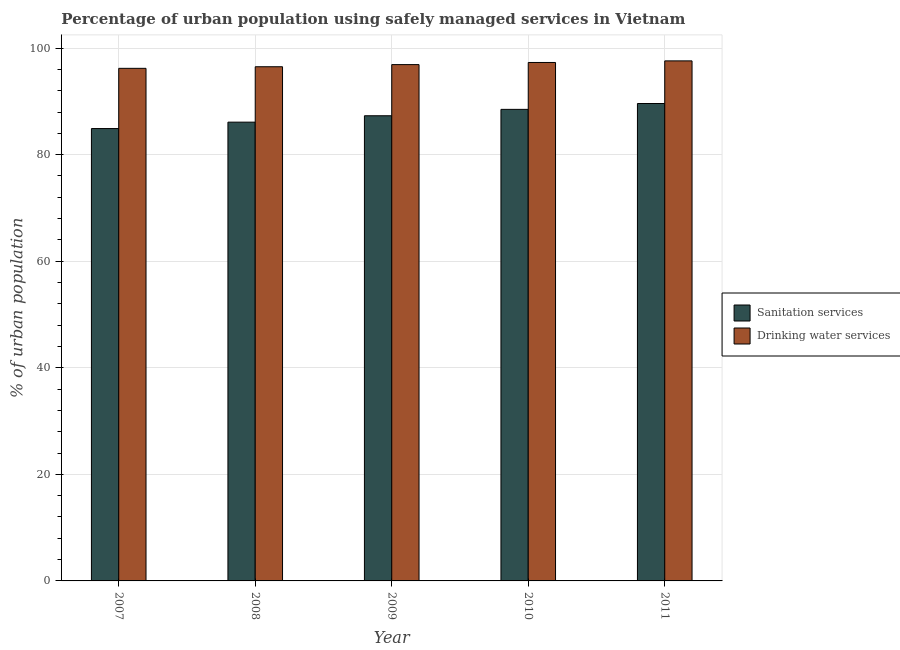How many different coloured bars are there?
Your answer should be very brief. 2. How many groups of bars are there?
Offer a very short reply. 5. How many bars are there on the 5th tick from the right?
Make the answer very short. 2. In how many cases, is the number of bars for a given year not equal to the number of legend labels?
Keep it short and to the point. 0. What is the percentage of urban population who used sanitation services in 2008?
Keep it short and to the point. 86.1. Across all years, what is the maximum percentage of urban population who used sanitation services?
Your answer should be compact. 89.6. Across all years, what is the minimum percentage of urban population who used drinking water services?
Make the answer very short. 96.2. In which year was the percentage of urban population who used drinking water services maximum?
Offer a very short reply. 2011. In which year was the percentage of urban population who used sanitation services minimum?
Your response must be concise. 2007. What is the total percentage of urban population who used drinking water services in the graph?
Ensure brevity in your answer.  484.5. What is the difference between the percentage of urban population who used drinking water services in 2008 and that in 2011?
Your answer should be very brief. -1.1. What is the difference between the percentage of urban population who used sanitation services in 2007 and the percentage of urban population who used drinking water services in 2009?
Offer a very short reply. -2.4. What is the average percentage of urban population who used drinking water services per year?
Offer a very short reply. 96.9. In the year 2009, what is the difference between the percentage of urban population who used drinking water services and percentage of urban population who used sanitation services?
Your answer should be compact. 0. What is the ratio of the percentage of urban population who used drinking water services in 2009 to that in 2011?
Give a very brief answer. 0.99. What is the difference between the highest and the second highest percentage of urban population who used sanitation services?
Give a very brief answer. 1.1. What is the difference between the highest and the lowest percentage of urban population who used sanitation services?
Ensure brevity in your answer.  4.7. In how many years, is the percentage of urban population who used drinking water services greater than the average percentage of urban population who used drinking water services taken over all years?
Your answer should be compact. 2. Is the sum of the percentage of urban population who used drinking water services in 2009 and 2011 greater than the maximum percentage of urban population who used sanitation services across all years?
Your answer should be very brief. Yes. What does the 2nd bar from the left in 2010 represents?
Provide a short and direct response. Drinking water services. What does the 2nd bar from the right in 2009 represents?
Offer a terse response. Sanitation services. Are all the bars in the graph horizontal?
Your answer should be very brief. No. Are the values on the major ticks of Y-axis written in scientific E-notation?
Give a very brief answer. No. Does the graph contain grids?
Keep it short and to the point. Yes. Where does the legend appear in the graph?
Ensure brevity in your answer.  Center right. How many legend labels are there?
Your answer should be compact. 2. What is the title of the graph?
Offer a very short reply. Percentage of urban population using safely managed services in Vietnam. Does "Revenue" appear as one of the legend labels in the graph?
Offer a very short reply. No. What is the label or title of the X-axis?
Ensure brevity in your answer.  Year. What is the label or title of the Y-axis?
Provide a short and direct response. % of urban population. What is the % of urban population in Sanitation services in 2007?
Provide a succinct answer. 84.9. What is the % of urban population in Drinking water services in 2007?
Keep it short and to the point. 96.2. What is the % of urban population in Sanitation services in 2008?
Give a very brief answer. 86.1. What is the % of urban population in Drinking water services in 2008?
Your answer should be very brief. 96.5. What is the % of urban population in Sanitation services in 2009?
Your answer should be compact. 87.3. What is the % of urban population of Drinking water services in 2009?
Your answer should be compact. 96.9. What is the % of urban population in Sanitation services in 2010?
Offer a very short reply. 88.5. What is the % of urban population in Drinking water services in 2010?
Provide a succinct answer. 97.3. What is the % of urban population in Sanitation services in 2011?
Offer a very short reply. 89.6. What is the % of urban population in Drinking water services in 2011?
Make the answer very short. 97.6. Across all years, what is the maximum % of urban population of Sanitation services?
Your response must be concise. 89.6. Across all years, what is the maximum % of urban population in Drinking water services?
Your answer should be very brief. 97.6. Across all years, what is the minimum % of urban population of Sanitation services?
Your answer should be very brief. 84.9. Across all years, what is the minimum % of urban population of Drinking water services?
Your answer should be compact. 96.2. What is the total % of urban population in Sanitation services in the graph?
Your answer should be compact. 436.4. What is the total % of urban population of Drinking water services in the graph?
Keep it short and to the point. 484.5. What is the difference between the % of urban population of Sanitation services in 2007 and that in 2008?
Make the answer very short. -1.2. What is the difference between the % of urban population in Sanitation services in 2007 and that in 2009?
Provide a succinct answer. -2.4. What is the difference between the % of urban population of Drinking water services in 2007 and that in 2009?
Your answer should be compact. -0.7. What is the difference between the % of urban population of Drinking water services in 2007 and that in 2010?
Offer a terse response. -1.1. What is the difference between the % of urban population in Sanitation services in 2007 and that in 2011?
Provide a succinct answer. -4.7. What is the difference between the % of urban population of Drinking water services in 2007 and that in 2011?
Make the answer very short. -1.4. What is the difference between the % of urban population of Sanitation services in 2008 and that in 2011?
Provide a succinct answer. -3.5. What is the difference between the % of urban population of Drinking water services in 2008 and that in 2011?
Provide a succinct answer. -1.1. What is the difference between the % of urban population in Sanitation services in 2009 and that in 2010?
Make the answer very short. -1.2. What is the difference between the % of urban population of Sanitation services in 2009 and that in 2011?
Your response must be concise. -2.3. What is the difference between the % of urban population of Sanitation services in 2010 and that in 2011?
Provide a succinct answer. -1.1. What is the difference between the % of urban population of Drinking water services in 2010 and that in 2011?
Offer a very short reply. -0.3. What is the difference between the % of urban population of Sanitation services in 2007 and the % of urban population of Drinking water services in 2011?
Make the answer very short. -12.7. What is the difference between the % of urban population in Sanitation services in 2008 and the % of urban population in Drinking water services in 2009?
Your answer should be compact. -10.8. What is the difference between the % of urban population of Sanitation services in 2008 and the % of urban population of Drinking water services in 2011?
Provide a short and direct response. -11.5. What is the difference between the % of urban population in Sanitation services in 2009 and the % of urban population in Drinking water services in 2011?
Give a very brief answer. -10.3. What is the difference between the % of urban population in Sanitation services in 2010 and the % of urban population in Drinking water services in 2011?
Your response must be concise. -9.1. What is the average % of urban population of Sanitation services per year?
Your answer should be very brief. 87.28. What is the average % of urban population of Drinking water services per year?
Make the answer very short. 96.9. In the year 2009, what is the difference between the % of urban population in Sanitation services and % of urban population in Drinking water services?
Ensure brevity in your answer.  -9.6. In the year 2010, what is the difference between the % of urban population of Sanitation services and % of urban population of Drinking water services?
Your response must be concise. -8.8. In the year 2011, what is the difference between the % of urban population in Sanitation services and % of urban population in Drinking water services?
Make the answer very short. -8. What is the ratio of the % of urban population of Sanitation services in 2007 to that in 2008?
Give a very brief answer. 0.99. What is the ratio of the % of urban population of Sanitation services in 2007 to that in 2009?
Provide a succinct answer. 0.97. What is the ratio of the % of urban population of Sanitation services in 2007 to that in 2010?
Offer a terse response. 0.96. What is the ratio of the % of urban population of Drinking water services in 2007 to that in 2010?
Make the answer very short. 0.99. What is the ratio of the % of urban population in Sanitation services in 2007 to that in 2011?
Your answer should be compact. 0.95. What is the ratio of the % of urban population in Drinking water services in 2007 to that in 2011?
Offer a very short reply. 0.99. What is the ratio of the % of urban population in Sanitation services in 2008 to that in 2009?
Offer a very short reply. 0.99. What is the ratio of the % of urban population of Sanitation services in 2008 to that in 2010?
Your answer should be very brief. 0.97. What is the ratio of the % of urban population of Sanitation services in 2008 to that in 2011?
Offer a very short reply. 0.96. What is the ratio of the % of urban population of Drinking water services in 2008 to that in 2011?
Give a very brief answer. 0.99. What is the ratio of the % of urban population in Sanitation services in 2009 to that in 2010?
Give a very brief answer. 0.99. What is the ratio of the % of urban population in Drinking water services in 2009 to that in 2010?
Offer a very short reply. 1. What is the ratio of the % of urban population in Sanitation services in 2009 to that in 2011?
Your answer should be compact. 0.97. What is the ratio of the % of urban population of Drinking water services in 2009 to that in 2011?
Give a very brief answer. 0.99. What is the ratio of the % of urban population of Sanitation services in 2010 to that in 2011?
Give a very brief answer. 0.99. What is the ratio of the % of urban population of Drinking water services in 2010 to that in 2011?
Your response must be concise. 1. What is the difference between the highest and the lowest % of urban population in Drinking water services?
Keep it short and to the point. 1.4. 